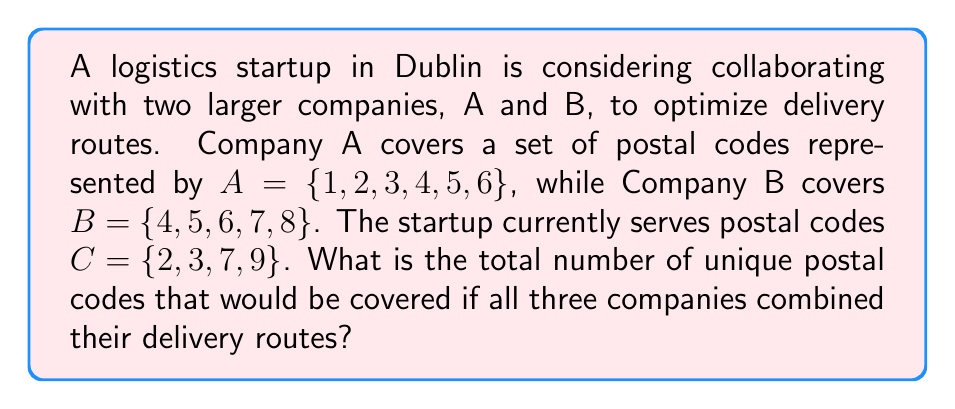Can you solve this math problem? To solve this problem, we need to find the union of the three sets A, B, and C. The union of sets includes all unique elements from all sets without repetition.

Let's approach this step-by-step:

1) First, let's list out all the elements in each set:
   $A = \{1, 2, 3, 4, 5, 6\}$
   $B = \{4, 5, 6, 7, 8\}$
   $C = \{2, 3, 7, 9\}$

2) Now, we need to combine all these elements, keeping only unique values:
   $A \cup B \cup C = \{1, 2, 3, 4, 5, 6, 7, 8, 9\}$

3) To count the elements:
   - 1 is unique to A
   - 2 and 3 are in both A and C
   - 4, 5, and 6 are in both A and B
   - 7 is in both B and C
   - 8 is unique to B
   - 9 is unique to C

4) Counting these unique elements: 1 + 2 + 3 + 4 + 5 + 6 + 7 + 8 + 9 = 9

Therefore, the union of all three sets contains 9 unique postal codes.
Answer: 9 postal codes 